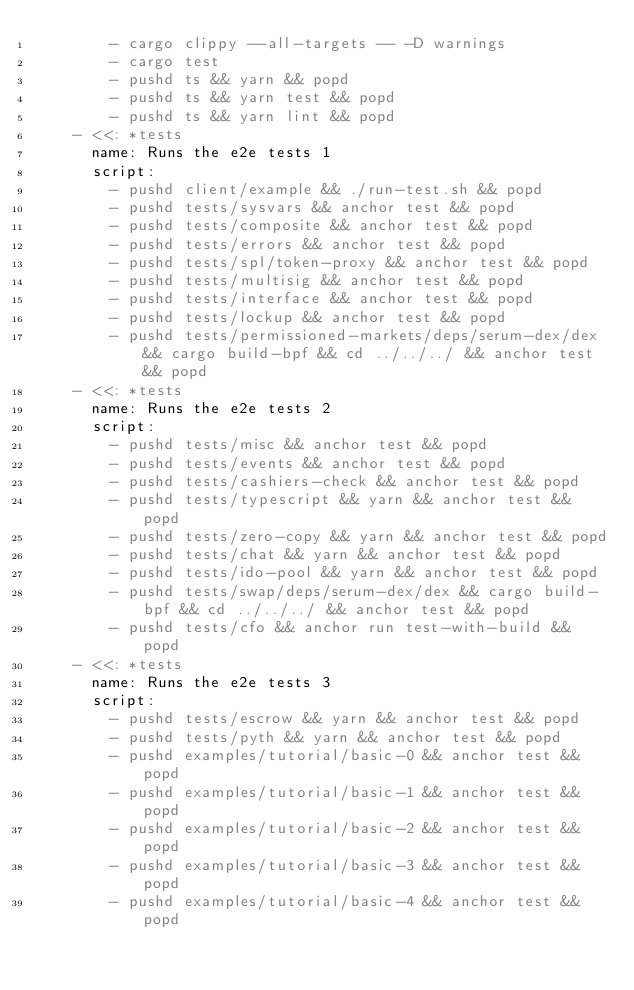Convert code to text. <code><loc_0><loc_0><loc_500><loc_500><_YAML_>        - cargo clippy --all-targets -- -D warnings
        - cargo test
        - pushd ts && yarn && popd
        - pushd ts && yarn test && popd
        - pushd ts && yarn lint && popd
    - <<: *tests
      name: Runs the e2e tests 1
      script:
        - pushd client/example && ./run-test.sh && popd
        - pushd tests/sysvars && anchor test && popd
        - pushd tests/composite && anchor test && popd
        - pushd tests/errors && anchor test && popd
        - pushd tests/spl/token-proxy && anchor test && popd
        - pushd tests/multisig && anchor test && popd
        - pushd tests/interface && anchor test && popd
        - pushd tests/lockup && anchor test && popd
        - pushd tests/permissioned-markets/deps/serum-dex/dex && cargo build-bpf && cd ../../../ && anchor test && popd
    - <<: *tests
      name: Runs the e2e tests 2
      script:
        - pushd tests/misc && anchor test && popd
        - pushd tests/events && anchor test && popd
        - pushd tests/cashiers-check && anchor test && popd
        - pushd tests/typescript && yarn && anchor test && popd
        - pushd tests/zero-copy && yarn && anchor test && popd
        - pushd tests/chat && yarn && anchor test && popd
        - pushd tests/ido-pool && yarn && anchor test && popd
        - pushd tests/swap/deps/serum-dex/dex && cargo build-bpf && cd ../../../ && anchor test && popd
        - pushd tests/cfo && anchor run test-with-build && popd
    - <<: *tests
      name: Runs the e2e tests 3
      script:
        - pushd tests/escrow && yarn && anchor test && popd
        - pushd tests/pyth && yarn && anchor test && popd
        - pushd examples/tutorial/basic-0 && anchor test && popd
        - pushd examples/tutorial/basic-1 && anchor test && popd
        - pushd examples/tutorial/basic-2 && anchor test && popd
        - pushd examples/tutorial/basic-3 && anchor test && popd
        - pushd examples/tutorial/basic-4 && anchor test && popd
</code> 